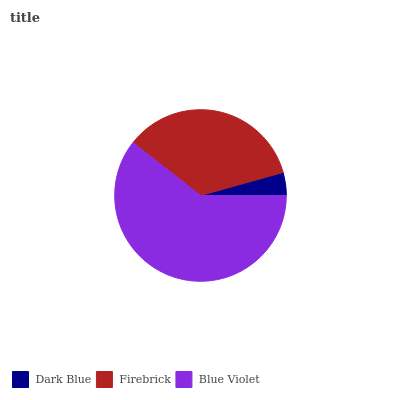Is Dark Blue the minimum?
Answer yes or no. Yes. Is Blue Violet the maximum?
Answer yes or no. Yes. Is Firebrick the minimum?
Answer yes or no. No. Is Firebrick the maximum?
Answer yes or no. No. Is Firebrick greater than Dark Blue?
Answer yes or no. Yes. Is Dark Blue less than Firebrick?
Answer yes or no. Yes. Is Dark Blue greater than Firebrick?
Answer yes or no. No. Is Firebrick less than Dark Blue?
Answer yes or no. No. Is Firebrick the high median?
Answer yes or no. Yes. Is Firebrick the low median?
Answer yes or no. Yes. Is Dark Blue the high median?
Answer yes or no. No. Is Blue Violet the low median?
Answer yes or no. No. 